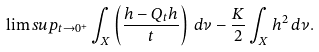Convert formula to latex. <formula><loc_0><loc_0><loc_500><loc_500>\lim s u p _ { t \to 0 ^ { + } } \int _ { X } \left ( \frac { h - Q _ { t } h } { t } \right ) \, d \nu - \frac { K } 2 \int _ { X } h ^ { 2 } \, d \nu .</formula> 